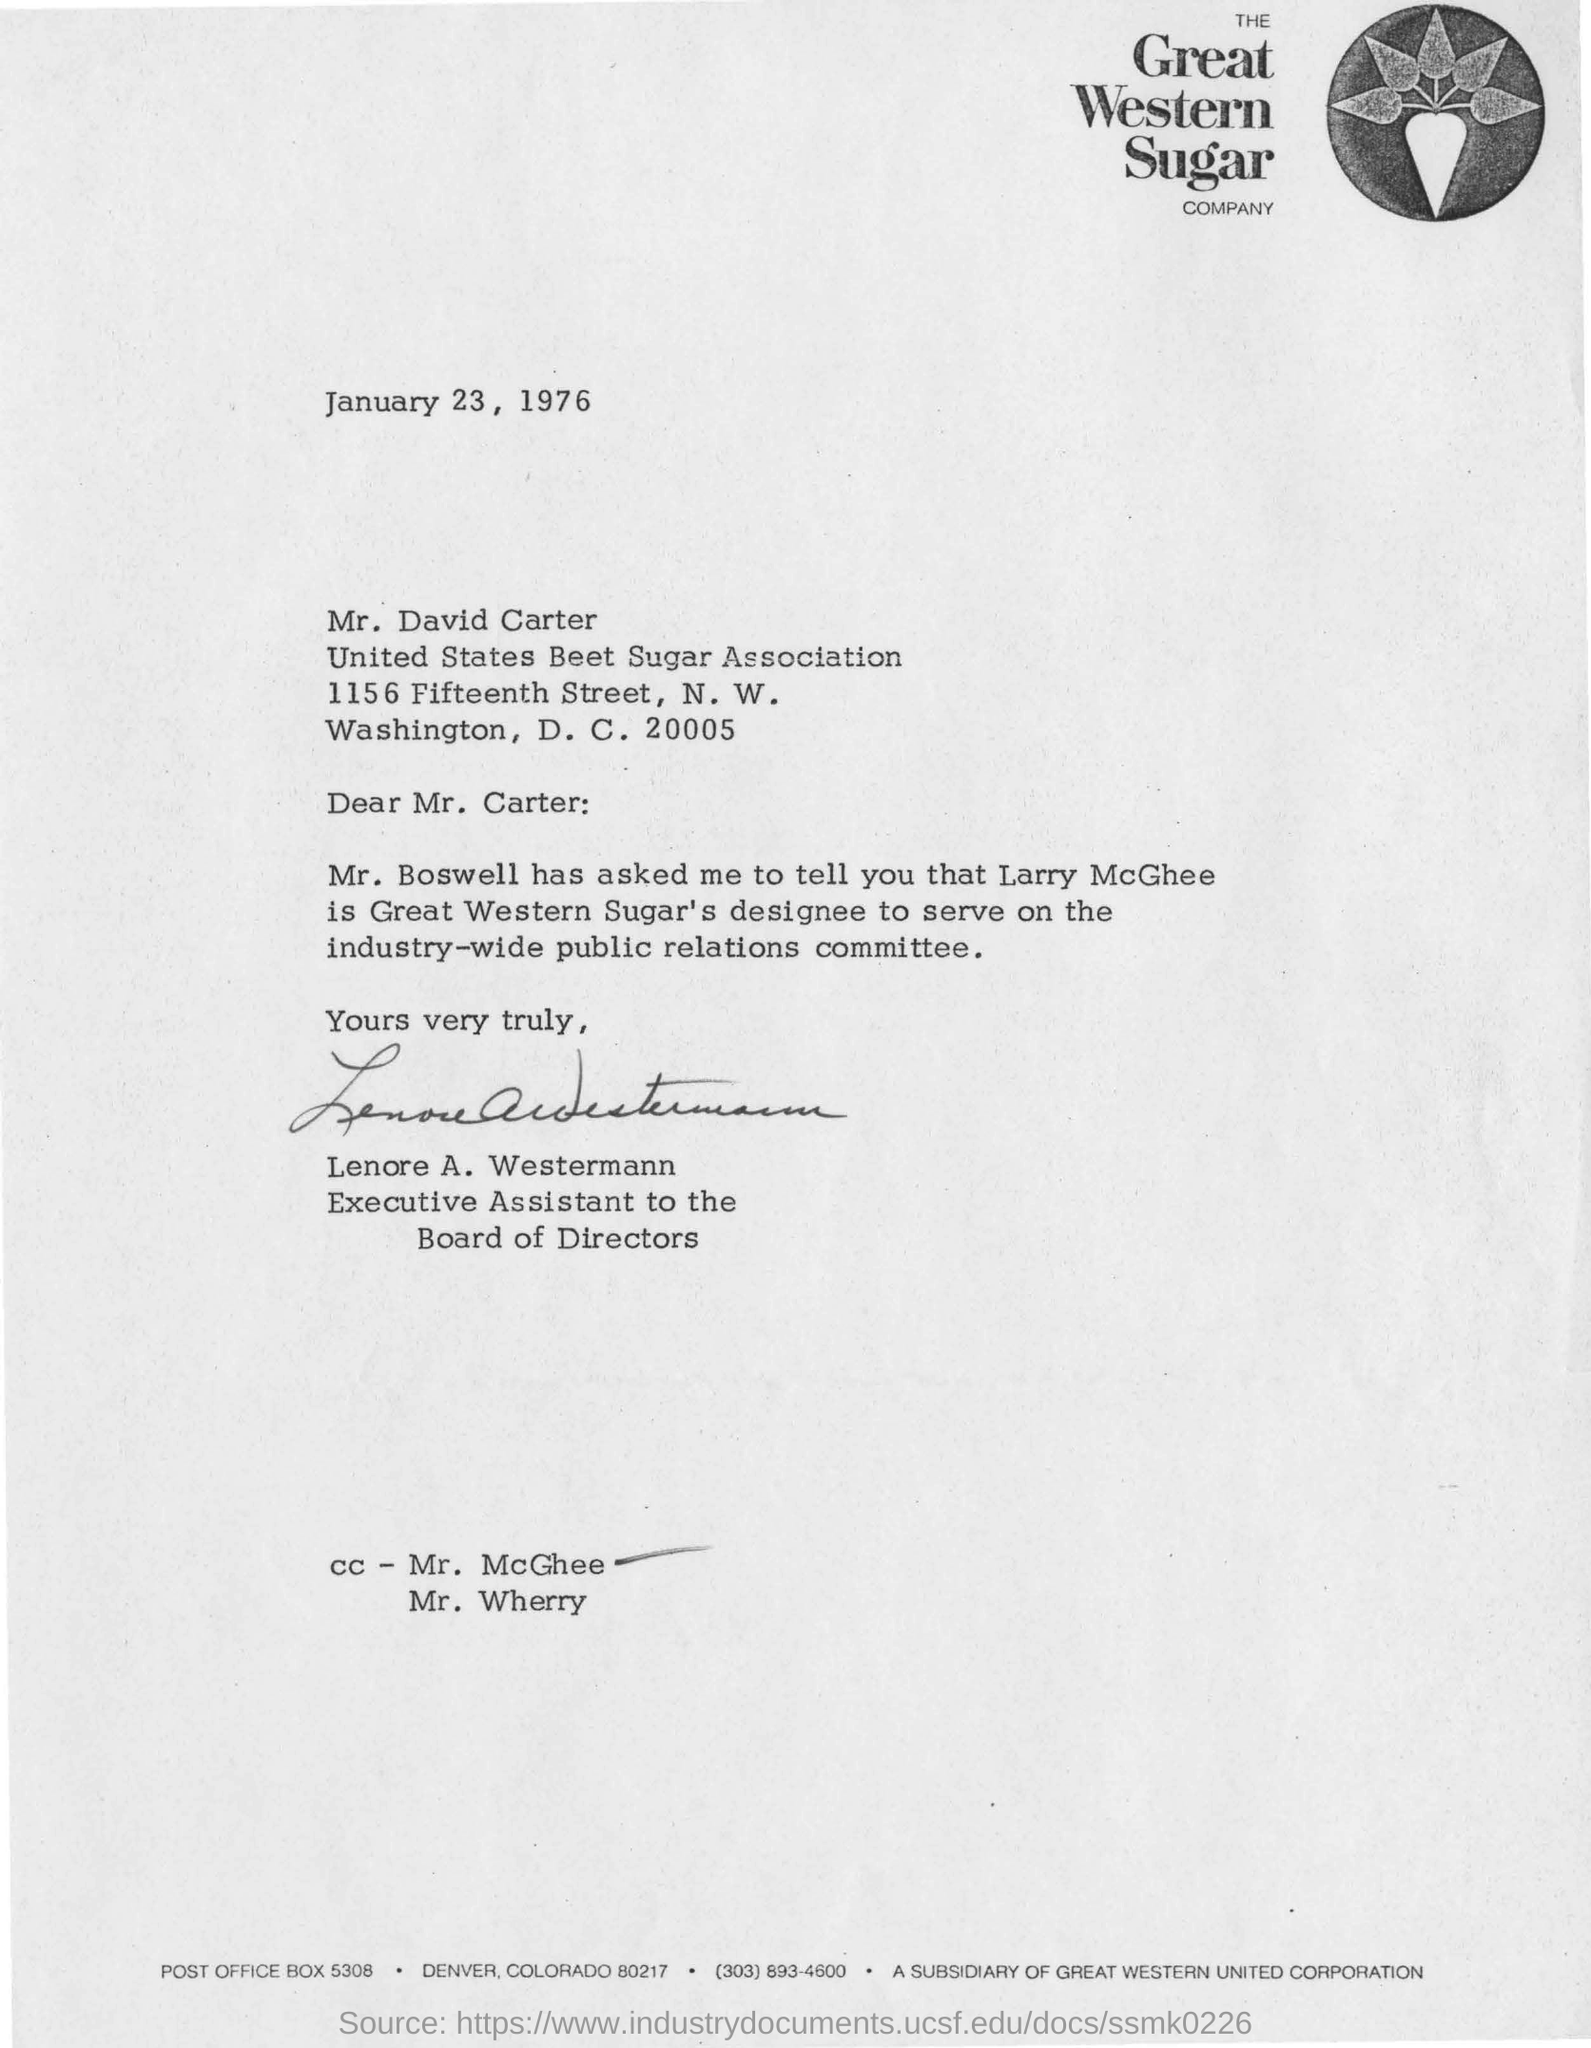Which is the date in the letter?
Provide a succinct answer. January 23, 1976. Who is the receiver of the letter?
Keep it short and to the point. Mr. David Carter. Who is the sender of the letter?
Offer a very short reply. Lenore A. Westermann. 